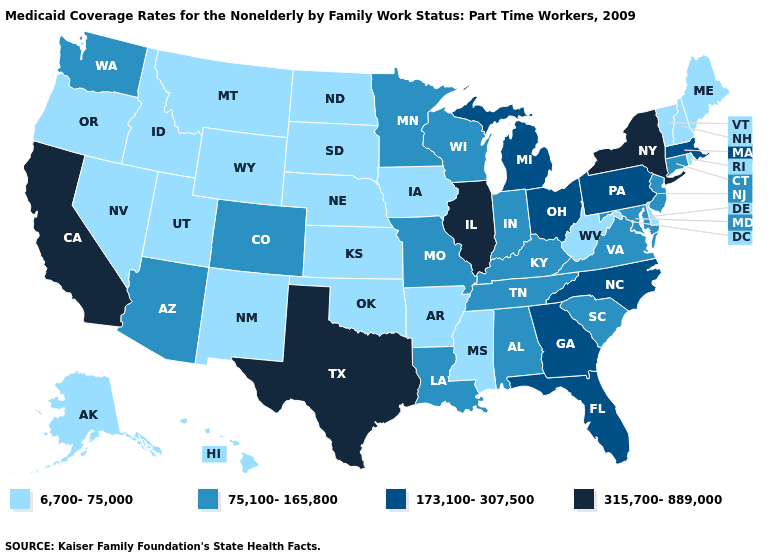What is the lowest value in the Northeast?
Be succinct. 6,700-75,000. What is the value of Utah?
Keep it brief. 6,700-75,000. Among the states that border Delaware , which have the lowest value?
Concise answer only. Maryland, New Jersey. Does Idaho have the highest value in the USA?
Be succinct. No. Name the states that have a value in the range 173,100-307,500?
Quick response, please. Florida, Georgia, Massachusetts, Michigan, North Carolina, Ohio, Pennsylvania. What is the lowest value in the USA?
Give a very brief answer. 6,700-75,000. What is the value of Louisiana?
Concise answer only. 75,100-165,800. What is the value of Virginia?
Be succinct. 75,100-165,800. What is the highest value in the USA?
Answer briefly. 315,700-889,000. What is the highest value in the USA?
Concise answer only. 315,700-889,000. Does the map have missing data?
Be succinct. No. What is the highest value in the USA?
Give a very brief answer. 315,700-889,000. What is the value of Vermont?
Write a very short answer. 6,700-75,000. Among the states that border California , does Arizona have the lowest value?
Give a very brief answer. No. How many symbols are there in the legend?
Write a very short answer. 4. 